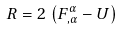Convert formula to latex. <formula><loc_0><loc_0><loc_500><loc_500>R = 2 \, \left ( F ^ { \alpha } _ { , \alpha } - U \right )</formula> 